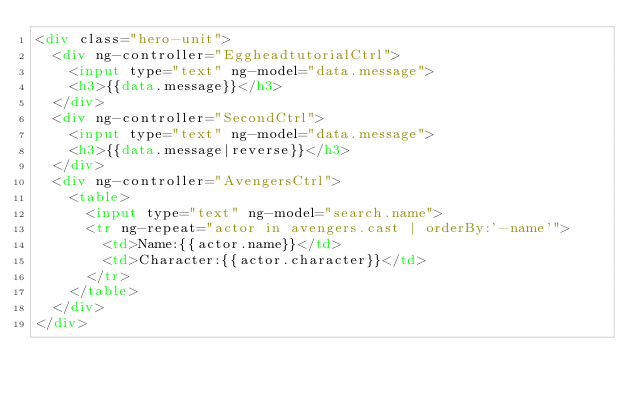<code> <loc_0><loc_0><loc_500><loc_500><_HTML_><div class="hero-unit">
  <div ng-controller="EggheadtutorialCtrl">
  	<input type="text" ng-model="data.message">
  	<h3>{{data.message}}</h3>
  </div>
  <div ng-controller="SecondCtrl">
  	<input type="text" ng-model="data.message">
  	<h3>{{data.message|reverse}}</h3>
  </div>
  <div ng-controller="AvengersCtrl">
    <table>
      <input type="text" ng-model="search.name">
      <tr ng-repeat="actor in avengers.cast | orderBy:'-name'">
        <td>Name:{{actor.name}}</td>
        <td>Character:{{actor.character}}</td>
      </tr>
    </table>
  </div> 
</div></code> 